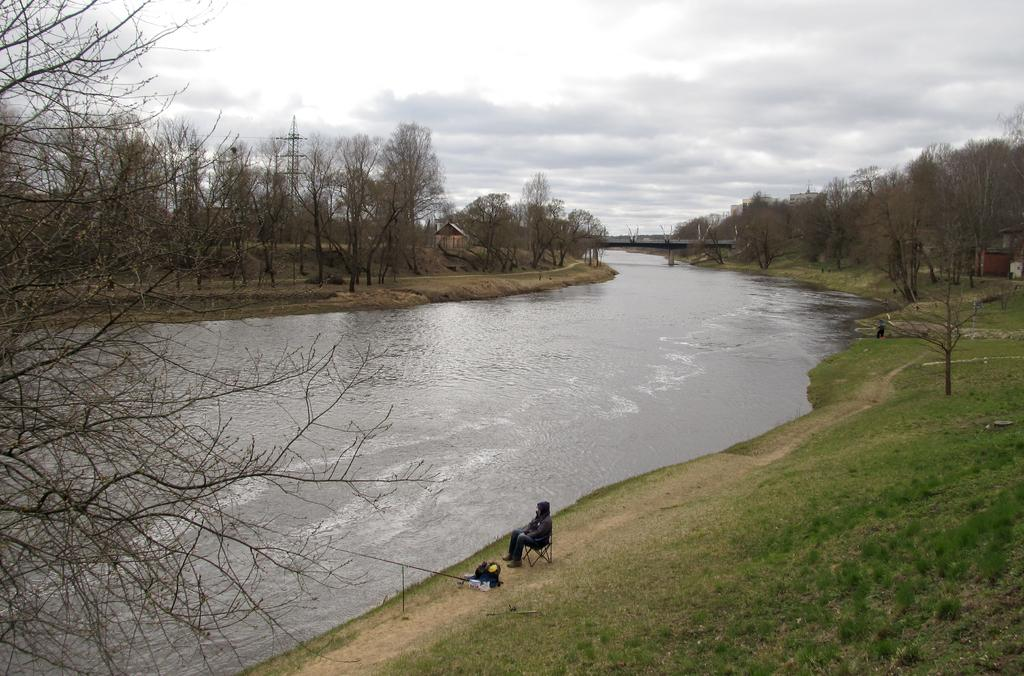Where was the image taken? The image is clicked outside. What can be seen in the middle of the image? There are trees and water in the middle of the image. Can you describe the person in the image? There is a person at the bottom of the image. What is visible at the top of the image? The sky is visible at the top of the image. How many goldfish are swimming in the water in the image? There are no goldfish visible in the image; it features trees and water. What type of shade is provided by the trees in the image? The image does not show any specific type of shade provided by the trees; it only shows the trees themselves. 